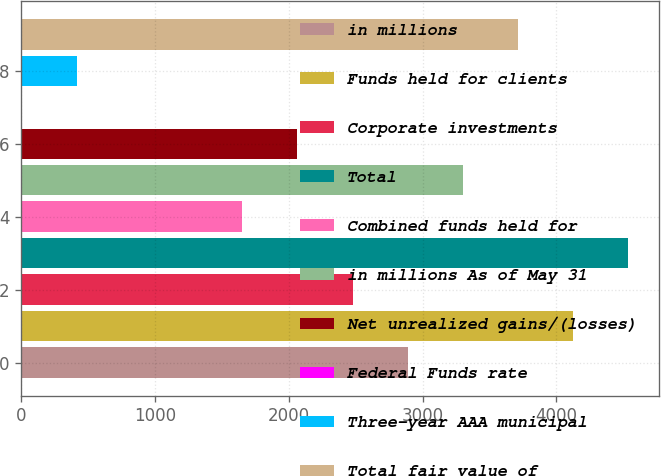Convert chart. <chart><loc_0><loc_0><loc_500><loc_500><bar_chart><fcel>in millions<fcel>Funds held for clients<fcel>Corporate investments<fcel>Total<fcel>Combined funds held for<fcel>in millions As of May 31<fcel>Net unrealized gains/(losses)<fcel>Federal Funds rate<fcel>Three-year AAA municipal<fcel>Total fair value of<nl><fcel>2888.52<fcel>4125.6<fcel>2476.16<fcel>4537.96<fcel>1651.44<fcel>3300.88<fcel>2063.8<fcel>2<fcel>414.36<fcel>3713.24<nl></chart> 